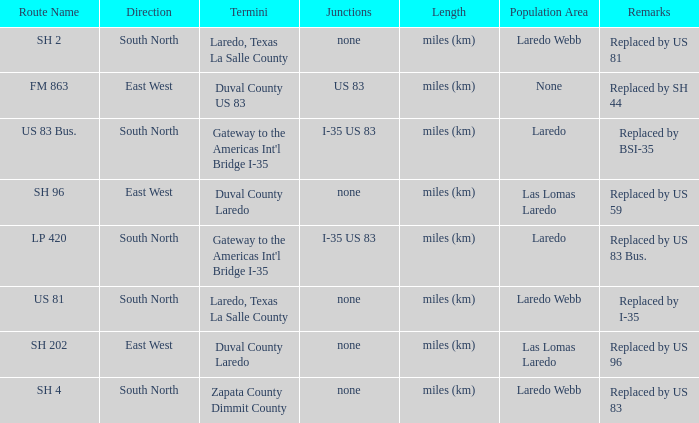How many termini are there that have "east west" listed in their direction section, "none" listed in their junction section, and have a route name of "sh 202"? 1.0. 